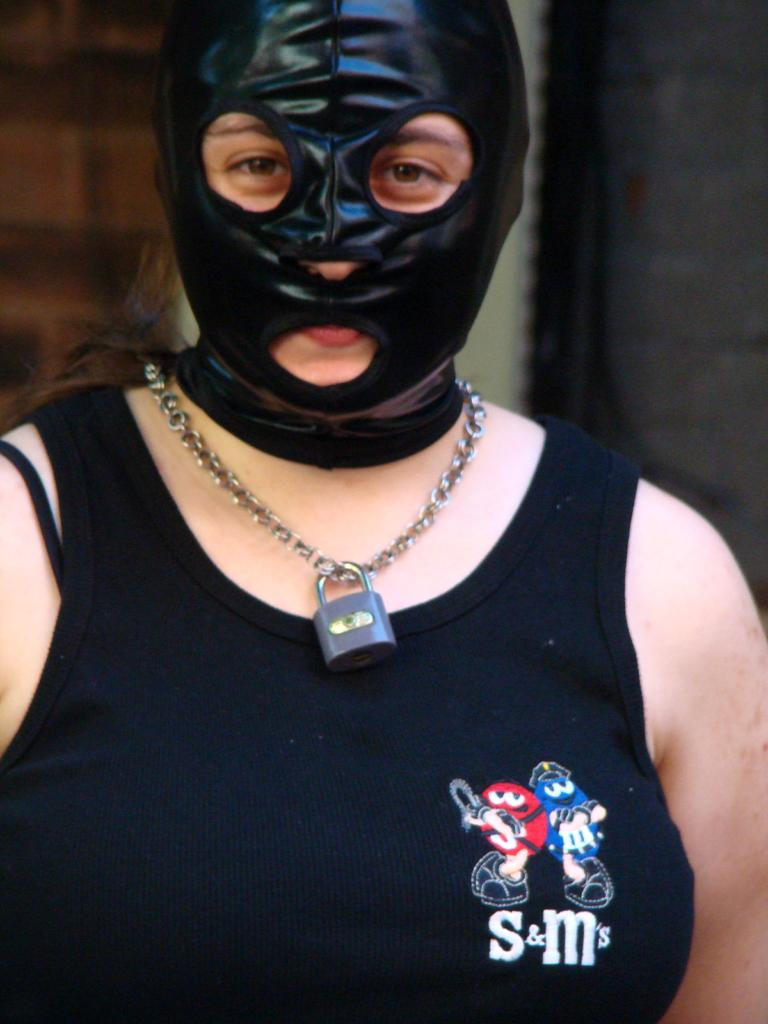Who is present in the image? There is a woman in the image. What is the woman doing in the image? The woman is standing in the image. What is the woman wearing on her face? The woman is wearing a mask on her face. What type of lace can be seen on the woman's skate in the image? There is no skate or lace present in the image; the woman is wearing a mask on her face. 